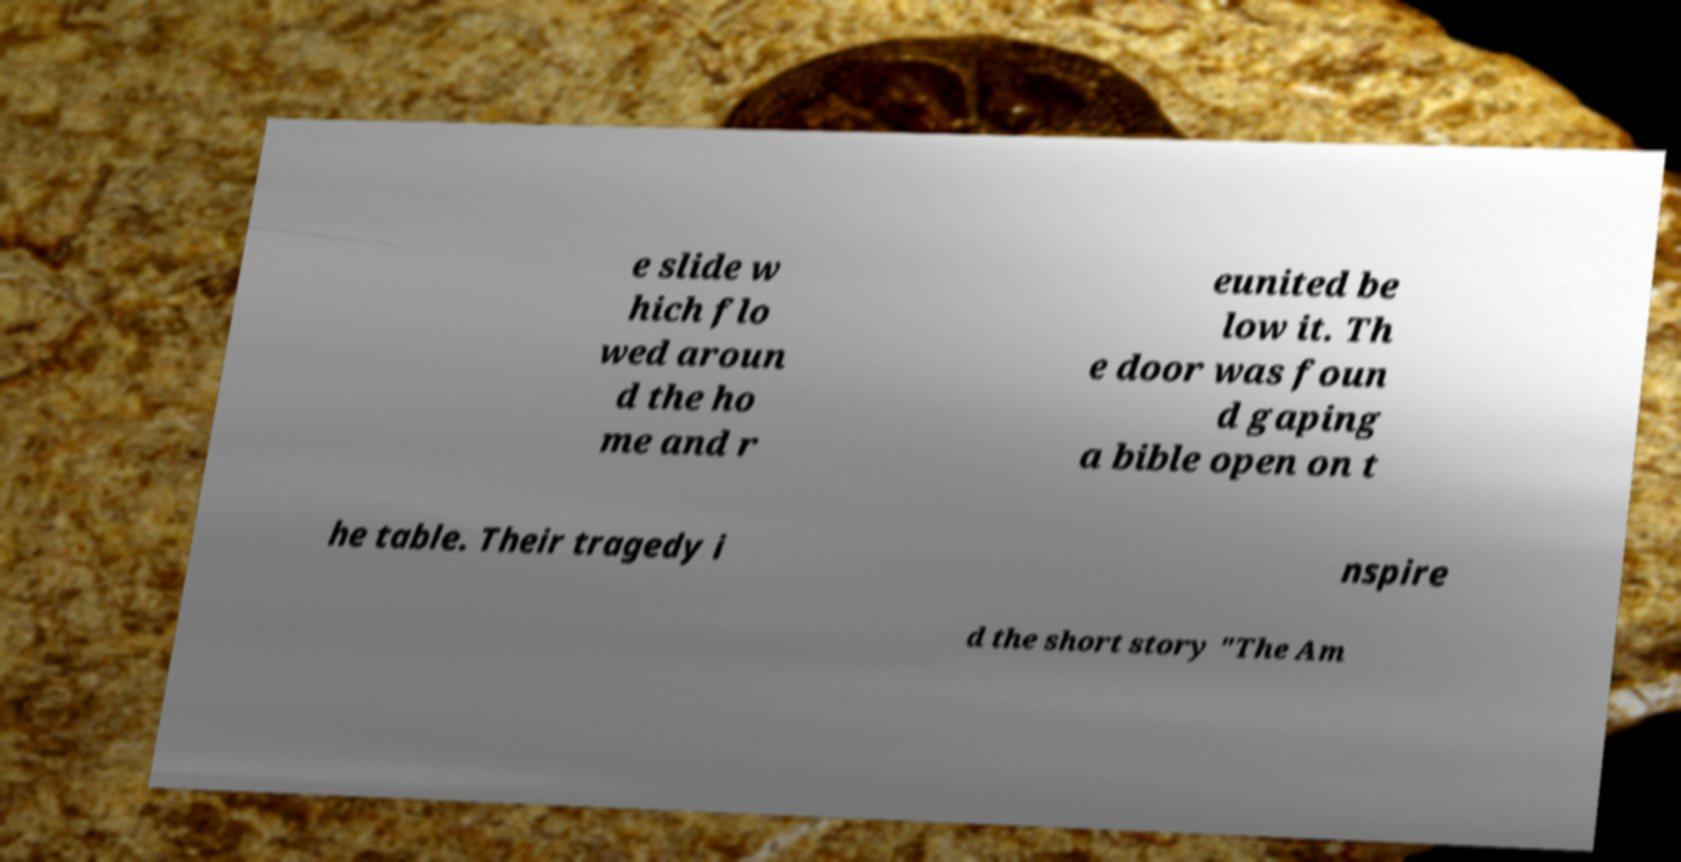There's text embedded in this image that I need extracted. Can you transcribe it verbatim? e slide w hich flo wed aroun d the ho me and r eunited be low it. Th e door was foun d gaping a bible open on t he table. Their tragedy i nspire d the short story "The Am 